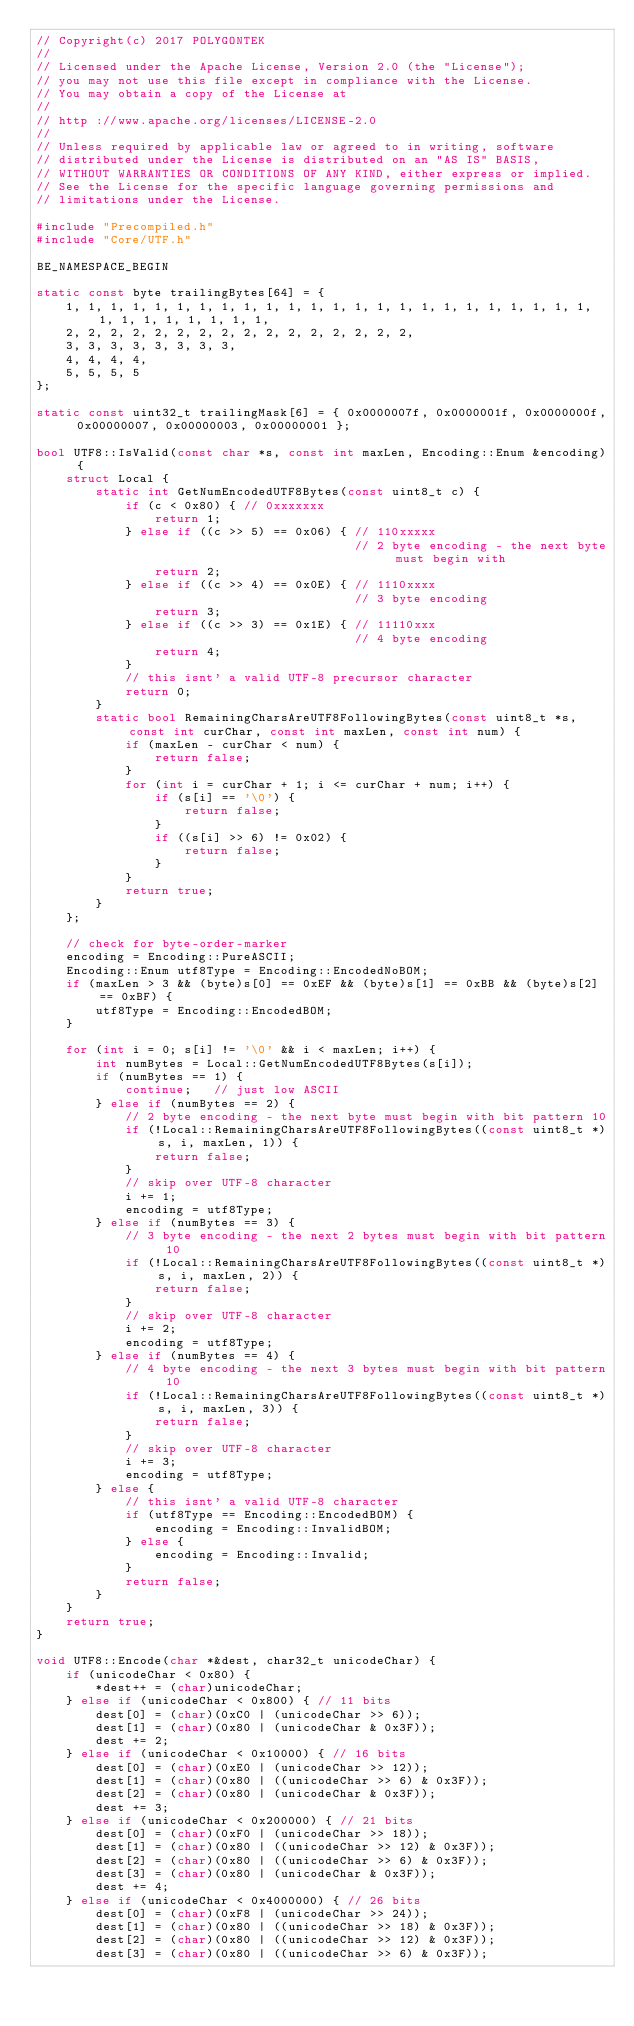<code> <loc_0><loc_0><loc_500><loc_500><_C++_>// Copyright(c) 2017 POLYGONTEK
// 
// Licensed under the Apache License, Version 2.0 (the "License");
// you may not use this file except in compliance with the License.
// You may obtain a copy of the License at
// 
// http ://www.apache.org/licenses/LICENSE-2.0
// 
// Unless required by applicable law or agreed to in writing, software
// distributed under the License is distributed on an "AS IS" BASIS,
// WITHOUT WARRANTIES OR CONDITIONS OF ANY KIND, either express or implied.
// See the License for the specific language governing permissions and
// limitations under the License.

#include "Precompiled.h"
#include "Core/UTF.h"

BE_NAMESPACE_BEGIN

static const byte trailingBytes[64] = {
    1, 1, 1, 1, 1, 1, 1, 1, 1, 1, 1, 1, 1, 1, 1, 1, 1, 1, 1, 1, 1, 1, 1, 1, 1, 1, 1, 1, 1, 1, 1, 1,
    2, 2, 2, 2, 2, 2, 2, 2, 2, 2, 2, 2, 2, 2, 2, 2,
    3, 3, 3, 3, 3, 3, 3, 3,
    4, 4, 4, 4,
    5, 5, 5, 5
};

static const uint32_t trailingMask[6] = { 0x0000007f, 0x0000001f, 0x0000000f, 0x00000007, 0x00000003, 0x00000001 };

bool UTF8::IsValid(const char *s, const int maxLen, Encoding::Enum &encoding) {
    struct Local {
        static int GetNumEncodedUTF8Bytes(const uint8_t c) {
            if (c < 0x80) { // 0xxxxxxx
                return 1;
            } else if ((c >> 5) == 0x06) { // 110xxxxx
                                           // 2 byte encoding - the next byte must begin with
                return 2;
            } else if ((c >> 4) == 0x0E) { // 1110xxxx
                                           // 3 byte encoding
                return 3;
            } else if ((c >> 3) == 0x1E) { // 11110xxx
                                           // 4 byte encoding
                return 4;
            }
            // this isnt' a valid UTF-8 precursor character
            return 0;
        }
        static bool RemainingCharsAreUTF8FollowingBytes(const uint8_t *s, const int curChar, const int maxLen, const int num) {
            if (maxLen - curChar < num) {
                return false;
            }
            for (int i = curChar + 1; i <= curChar + num; i++) {
                if (s[i] == '\0') {
                    return false;
                }
                if ((s[i] >> 6) != 0x02) {
                    return false;
                }
            }
            return true;
        }
    };

    // check for byte-order-marker
    encoding = Encoding::PureASCII;
    Encoding::Enum utf8Type = Encoding::EncodedNoBOM;
    if (maxLen > 3 && (byte)s[0] == 0xEF && (byte)s[1] == 0xBB && (byte)s[2] == 0xBF) {
        utf8Type = Encoding::EncodedBOM;
    }

    for (int i = 0; s[i] != '\0' && i < maxLen; i++) {
        int numBytes = Local::GetNumEncodedUTF8Bytes(s[i]);
        if (numBytes == 1) {
            continue;   // just low ASCII
        } else if (numBytes == 2) {
            // 2 byte encoding - the next byte must begin with bit pattern 10
            if (!Local::RemainingCharsAreUTF8FollowingBytes((const uint8_t *)s, i, maxLen, 1)) {
                return false;
            }
            // skip over UTF-8 character
            i += 1;
            encoding = utf8Type;
        } else if (numBytes == 3) {
            // 3 byte encoding - the next 2 bytes must begin with bit pattern 10
            if (!Local::RemainingCharsAreUTF8FollowingBytes((const uint8_t *)s, i, maxLen, 2)) {
                return false;
            }
            // skip over UTF-8 character
            i += 2;
            encoding = utf8Type;
        } else if (numBytes == 4) {
            // 4 byte encoding - the next 3 bytes must begin with bit pattern 10
            if (!Local::RemainingCharsAreUTF8FollowingBytes((const uint8_t *)s, i, maxLen, 3)) {
                return false;
            }
            // skip over UTF-8 character
            i += 3;
            encoding = utf8Type;
        } else {
            // this isnt' a valid UTF-8 character
            if (utf8Type == Encoding::EncodedBOM) {
                encoding = Encoding::InvalidBOM;
            } else {
                encoding = Encoding::Invalid;
            }
            return false;
        }
    }
    return true;
}

void UTF8::Encode(char *&dest, char32_t unicodeChar) {
    if (unicodeChar < 0x80) {
        *dest++ = (char)unicodeChar;
    } else if (unicodeChar < 0x800) { // 11 bits
        dest[0] = (char)(0xC0 | (unicodeChar >> 6));
        dest[1] = (char)(0x80 | (unicodeChar & 0x3F));
        dest += 2;
    } else if (unicodeChar < 0x10000) { // 16 bits
        dest[0] = (char)(0xE0 | (unicodeChar >> 12));
        dest[1] = (char)(0x80 | ((unicodeChar >> 6) & 0x3F));
        dest[2] = (char)(0x80 | (unicodeChar & 0x3F));
        dest += 3;
    } else if (unicodeChar < 0x200000) { // 21 bits
        dest[0] = (char)(0xF0 | (unicodeChar >> 18));
        dest[1] = (char)(0x80 | ((unicodeChar >> 12) & 0x3F));
        dest[2] = (char)(0x80 | ((unicodeChar >> 6) & 0x3F));
        dest[3] = (char)(0x80 | (unicodeChar & 0x3F));
        dest += 4;
    } else if (unicodeChar < 0x4000000) { // 26 bits
        dest[0] = (char)(0xF8 | (unicodeChar >> 24));
        dest[1] = (char)(0x80 | ((unicodeChar >> 18) & 0x3F));
        dest[2] = (char)(0x80 | ((unicodeChar >> 12) & 0x3F));
        dest[3] = (char)(0x80 | ((unicodeChar >> 6) & 0x3F));</code> 